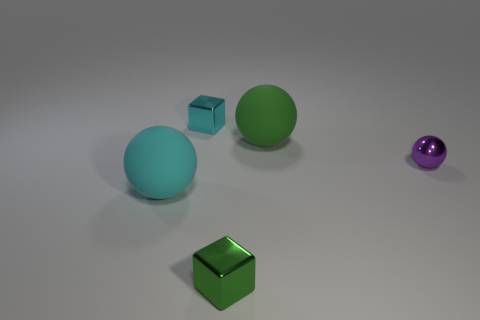There is a ball on the left side of the big rubber thing that is to the right of the cyan metal thing; what is its color? The ball located to the left of the big rubber object, which is itself to the right of the cyan metal thing, features a soothing shade of green, akin to the color of fresh spring leaves. 